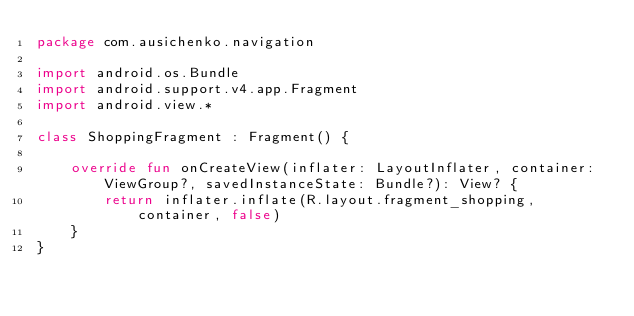Convert code to text. <code><loc_0><loc_0><loc_500><loc_500><_Kotlin_>package com.ausichenko.navigation

import android.os.Bundle
import android.support.v4.app.Fragment
import android.view.*

class ShoppingFragment : Fragment() {

    override fun onCreateView(inflater: LayoutInflater, container: ViewGroup?, savedInstanceState: Bundle?): View? {
        return inflater.inflate(R.layout.fragment_shopping, container, false)
    }
}</code> 